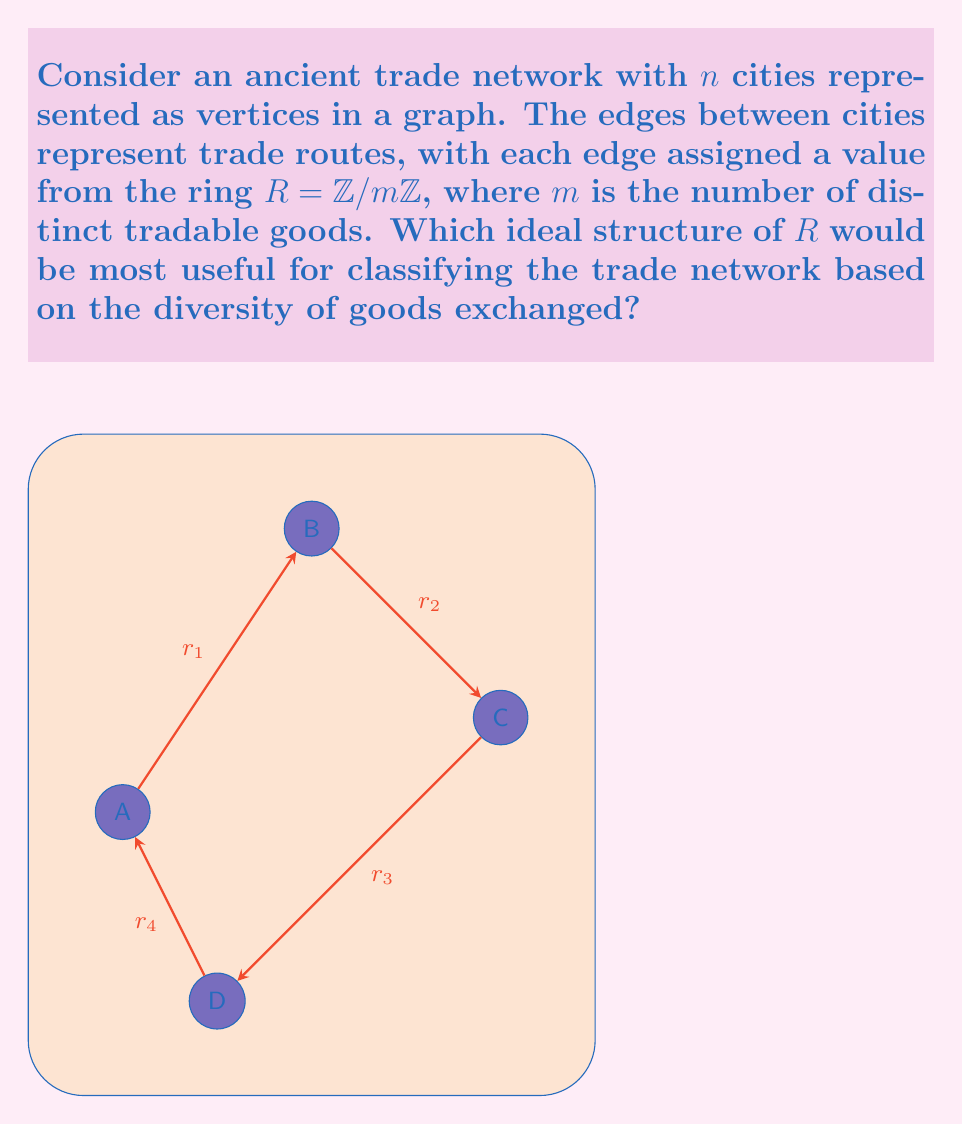Can you answer this question? To classify the ancient trade network based on the diversity of goods exchanged, we need to consider the ideal structure of the ring $R = \mathbb{Z}/m\mathbb{Z}$. Let's approach this step-by-step:

1) In ring theory, ideals are important substructures that can provide information about the ring's properties.

2) For $R = \mathbb{Z}/m\mathbb{Z}$, the ideals are precisely the subgroups of the additive group of $R$.

3) The subgroups of $\mathbb{Z}/m\mathbb{Z}$ are of the form $\langle d \rangle$, where $d$ is a divisor of $m$.

4) The number of ideals in $R$ is equal to the number of divisors of $m$.

5) For classifying trade networks, we want to maximize the number of possible classifications, which means maximizing the number of ideals.

6) The number of divisors is maximized when $m$ is a highly composite number, specifically when $m = 2^a 3^b 5^c ...$, where $a, b, c, ...$ are positive integers.

7) Among numbers with the same magnitude, those with more prime factors tend to have more divisors.

8) In the context of trade networks, this means choosing $m$ to be a product of small prime numbers, representing different categories of goods (e.g., 2 for perishable/non-perishable, 3 for luxury/common/essential, 5 for different material types).

9) The ideal structure in this case would allow for a fine-grained classification of trade routes based on the types of goods exchanged, represented by the different prime factors of $m$.

Therefore, the most useful ideal structure for classifying the trade network would be one where $m$ is a product of small distinct primes, maximizing the number of ideals and thus the number of possible classifications.
Answer: Ideal structure with $m = 2^a 3^b 5^c ...$, where $a, b, c, ...$ are small positive integers. 